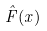Convert formula to latex. <formula><loc_0><loc_0><loc_500><loc_500>\hat { F } ( x )</formula> 